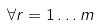<formula> <loc_0><loc_0><loc_500><loc_500>\forall r = 1 \dots m</formula> 